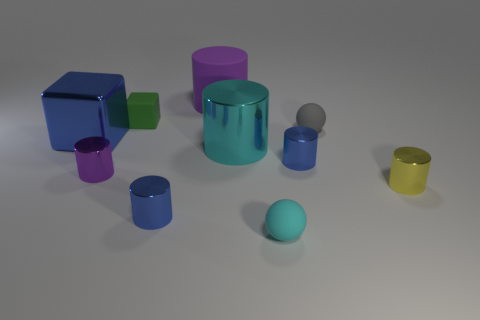Are there more gray spheres than large brown shiny cylinders?
Your answer should be very brief. Yes. What number of things are large cylinders behind the blue metal cube or green rubber cubes?
Your answer should be very brief. 2. Are there any blocks that have the same size as the cyan rubber sphere?
Provide a succinct answer. Yes. Is the number of blue metal blocks less than the number of things?
Keep it short and to the point. Yes. What number of cubes are yellow objects or blue shiny objects?
Keep it short and to the point. 1. What number of tiny metallic objects have the same color as the metal cube?
Your answer should be compact. 2. There is a rubber object that is behind the cyan sphere and on the right side of the big rubber cylinder; how big is it?
Offer a very short reply. Small. Is the number of small blue metallic objects in front of the purple metallic cylinder less than the number of large cubes?
Make the answer very short. No. Is the big purple object made of the same material as the big cyan cylinder?
Your answer should be very brief. No. What number of things are either big metal cubes or metallic cylinders?
Give a very brief answer. 6. 